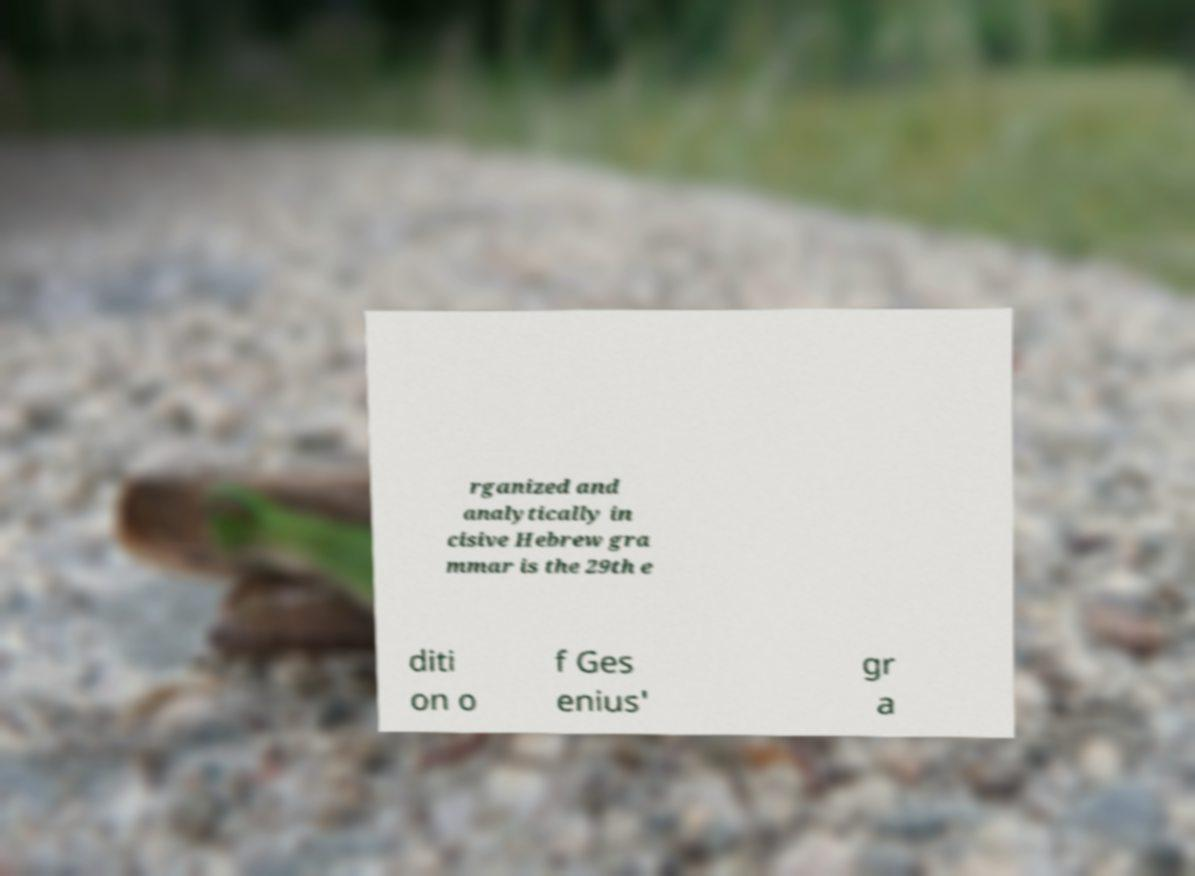Can you read and provide the text displayed in the image?This photo seems to have some interesting text. Can you extract and type it out for me? rganized and analytically in cisive Hebrew gra mmar is the 29th e diti on o f Ges enius' gr a 